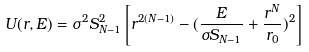Convert formula to latex. <formula><loc_0><loc_0><loc_500><loc_500>U ( r , E ) = \sigma ^ { 2 } S _ { N - 1 } ^ { 2 } \left [ r ^ { 2 ( N - 1 ) } - ( \frac { E } { \sigma S _ { N - 1 } } + \frac { r ^ { N } } { r _ { 0 } } ) ^ { 2 } \right ]</formula> 